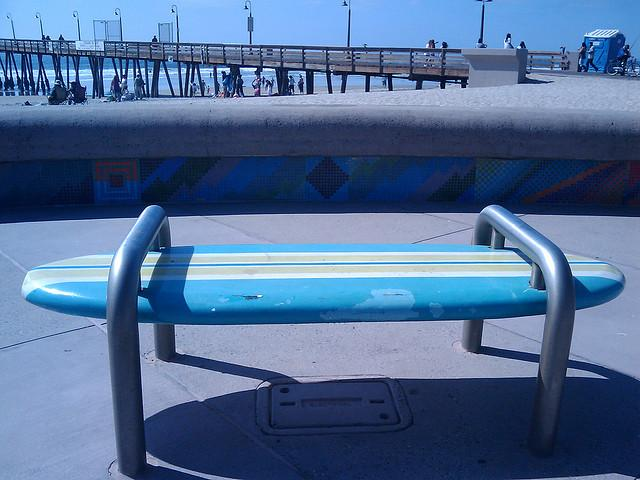What are the bars touching in the foreground? Please explain your reasoning. surf board. The bars are on a bench that looks like it is for riding the waves. 